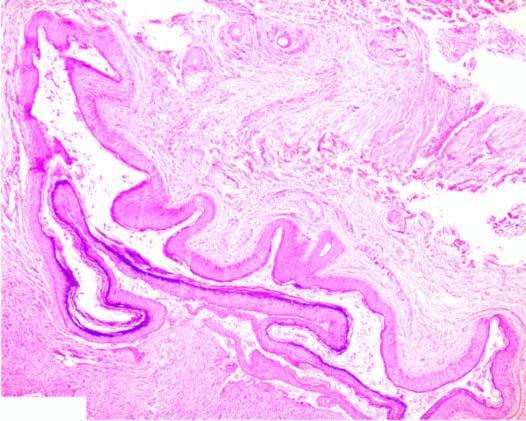does dermoid cyst have adnexal structures in the cyst wall ie in addition to features of epidermal cyst?
Answer the question using a single word or phrase. Yes 